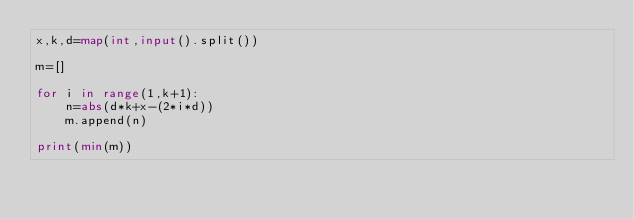<code> <loc_0><loc_0><loc_500><loc_500><_Python_>x,k,d=map(int,input().split())

m=[]

for i in range(1,k+1):
    n=abs(d*k+x-(2*i*d))
    m.append(n)
    
print(min(m))</code> 